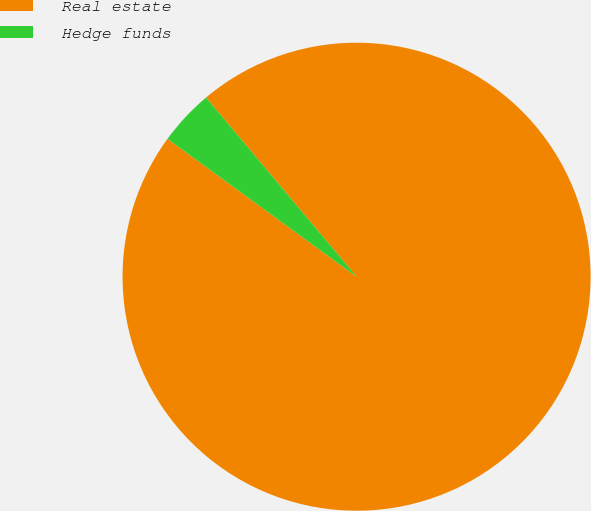Convert chart to OTSL. <chart><loc_0><loc_0><loc_500><loc_500><pie_chart><fcel>Real estate<fcel>Hedge funds<nl><fcel>96.15%<fcel>3.85%<nl></chart> 